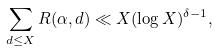Convert formula to latex. <formula><loc_0><loc_0><loc_500><loc_500>\sum _ { d \leq X } R ( \alpha , d ) \ll X ( \log X ) ^ { \delta - 1 } ,</formula> 